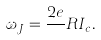Convert formula to latex. <formula><loc_0><loc_0><loc_500><loc_500>\omega _ { J } = \frac { 2 e } { } R I _ { c } .</formula> 